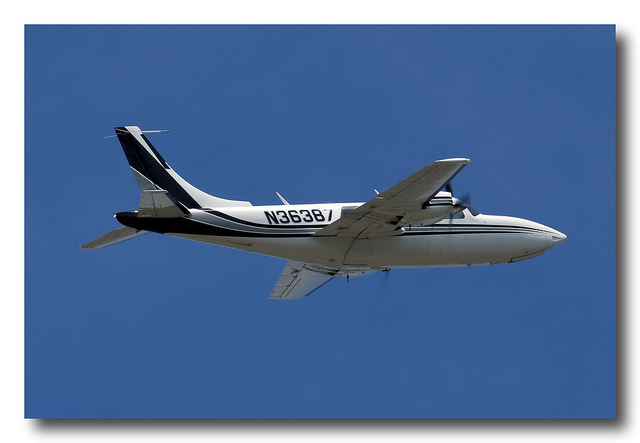Identify the text contained in this image. N36387 